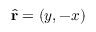Convert formula to latex. <formula><loc_0><loc_0><loc_500><loc_500>\widehat { r } = ( y , - x )</formula> 